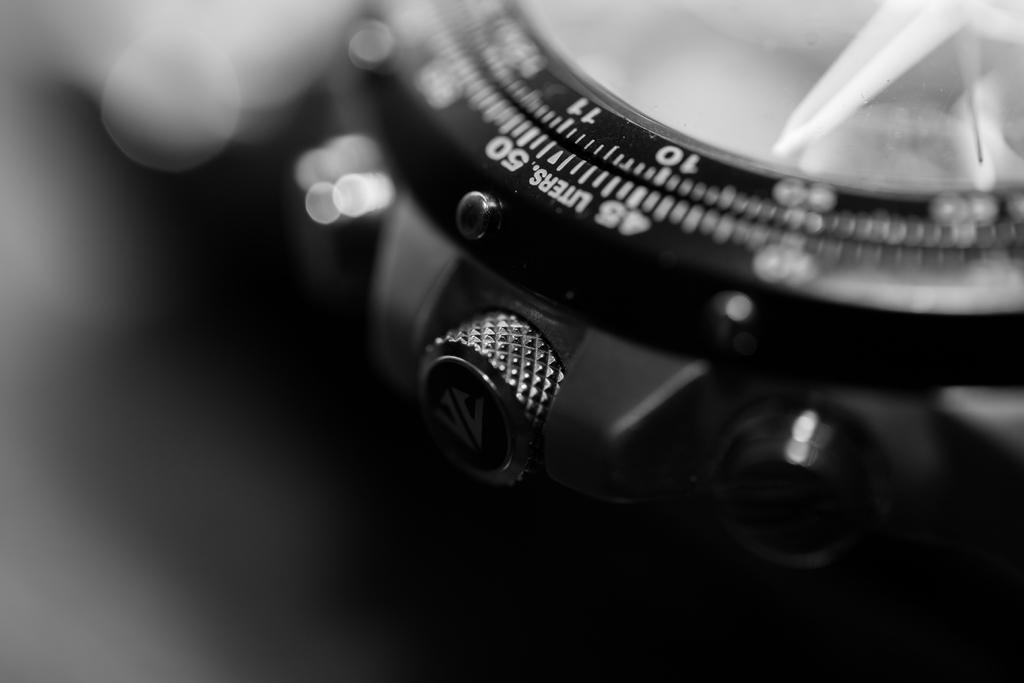What object is the main subject of the image? There is a watch in the image. What feature is present on the watch? The watch has numbers on it. Is there any text on the watch? Yes, there is a word written on the watch. How would you describe the background of the image? The background of the image is blurred. What type of stone is used to create the watch's band in the image? There is no mention of a watch band or any stone in the image; the watch has numbers and a word written on it. 